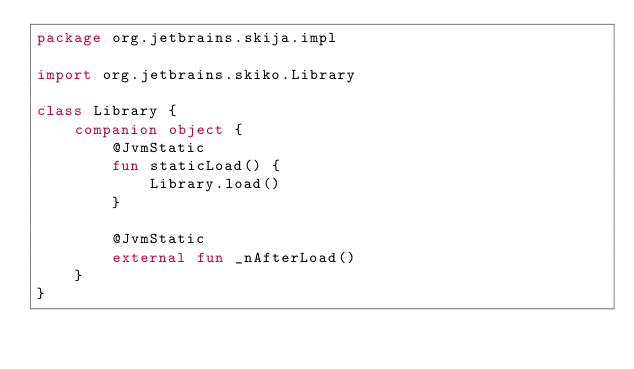<code> <loc_0><loc_0><loc_500><loc_500><_Kotlin_>package org.jetbrains.skija.impl

import org.jetbrains.skiko.Library

class Library {
    companion object {
        @JvmStatic
        fun staticLoad() {
            Library.load()
        }

        @JvmStatic
        external fun _nAfterLoad()
    }
}
</code> 